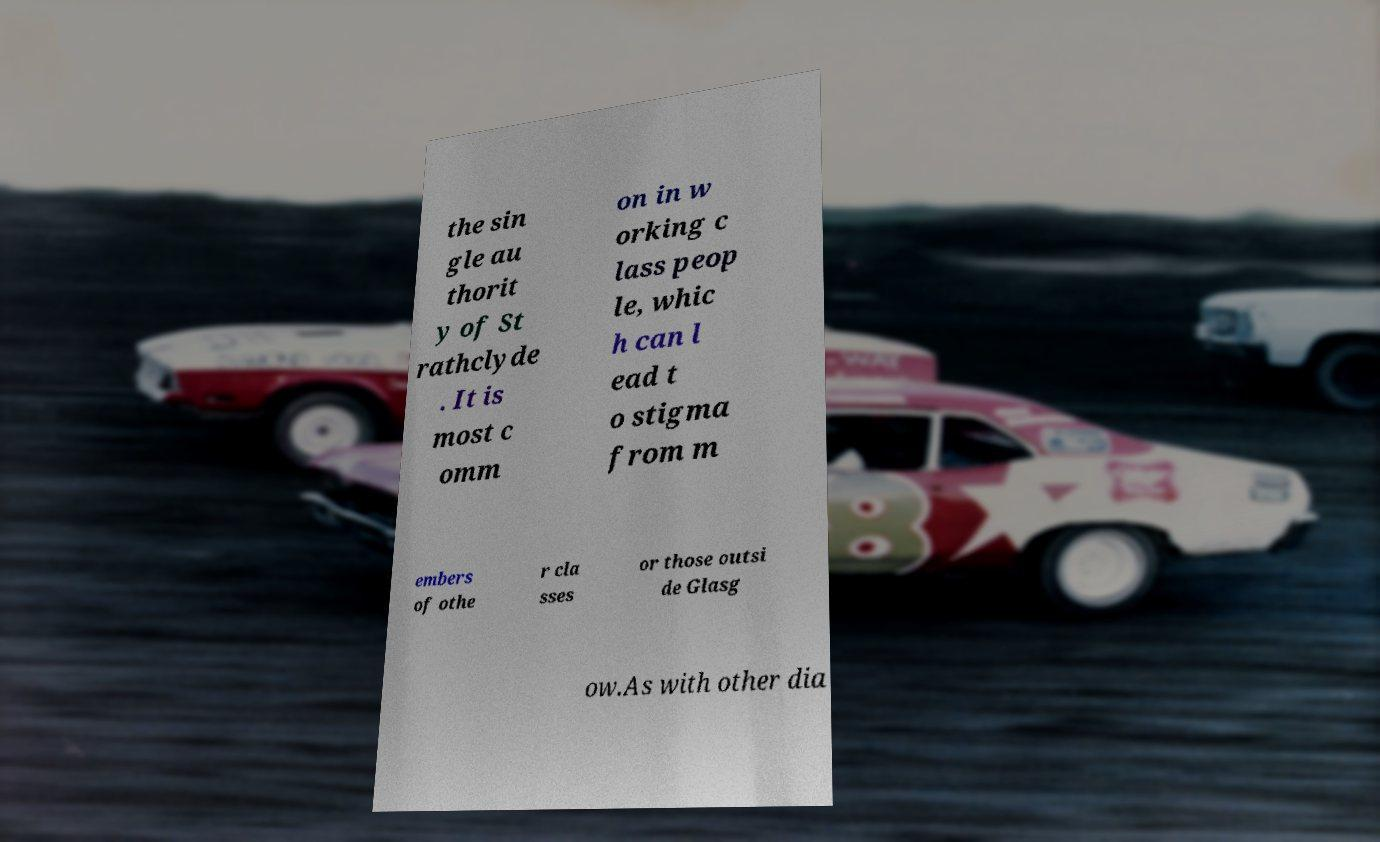There's text embedded in this image that I need extracted. Can you transcribe it verbatim? the sin gle au thorit y of St rathclyde . It is most c omm on in w orking c lass peop le, whic h can l ead t o stigma from m embers of othe r cla sses or those outsi de Glasg ow.As with other dia 